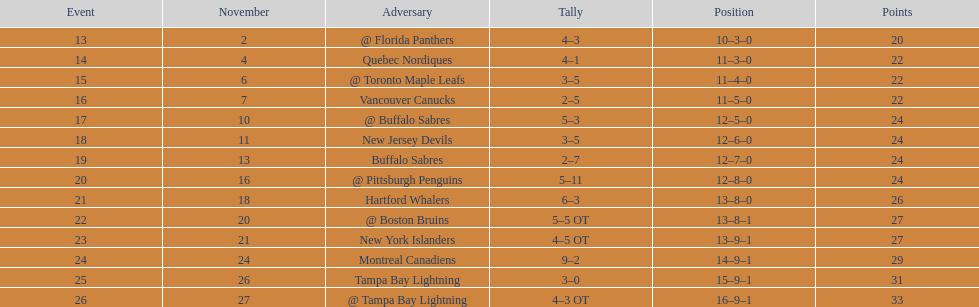What other team had the closest amount of wins? New York Islanders. 